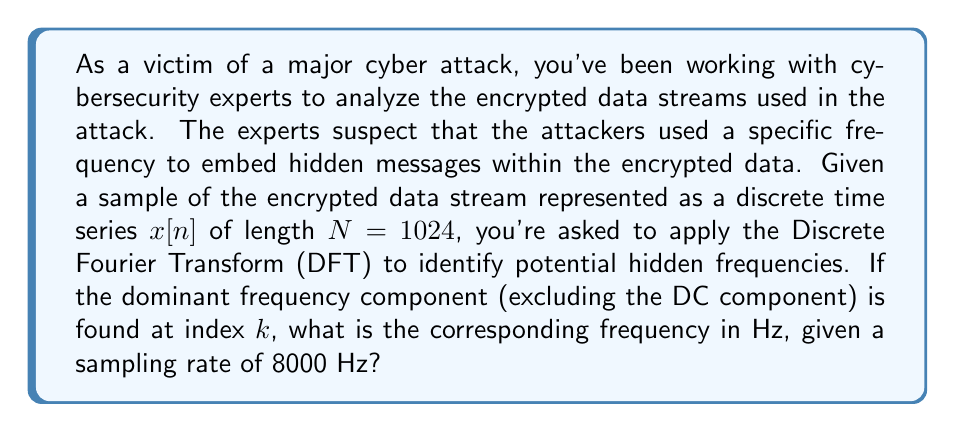Show me your answer to this math problem. To solve this problem, we need to follow these steps:

1) First, we apply the Discrete Fourier Transform (DFT) to the time series $x[n]$. The DFT is given by:

   $$X[k] = \sum_{n=0}^{N-1} x[n] e^{-j2\pi kn/N}$$

   where $k = 0, 1, ..., N-1$

2) After applying the DFT, we would examine the magnitude spectrum $|X[k]|$ to find the dominant frequency component, ignoring the DC component at $k=0$.

3) Once we have the index $k$ of the dominant frequency, we can calculate the actual frequency in Hz using the formula:

   $$f = \frac{k \cdot f_s}{N}$$

   where:
   - $f$ is the frequency in Hz
   - $k$ is the index of the frequency component
   - $f_s$ is the sampling rate (8000 Hz in this case)
   - $N$ is the length of the time series (1024 in this case)

4) Substituting the given values:

   $$f = \frac{k \cdot 8000}{1024}$$

5) Simplifying:

   $$f = \frac{125k}{16}$$

This formula gives us the frequency in Hz for any given index $k$.
Answer: The frequency corresponding to index $k$ is:

$$f = \frac{125k}{16} \text{ Hz}$$

where $k$ is the index of the dominant frequency component found in the DFT magnitude spectrum. 